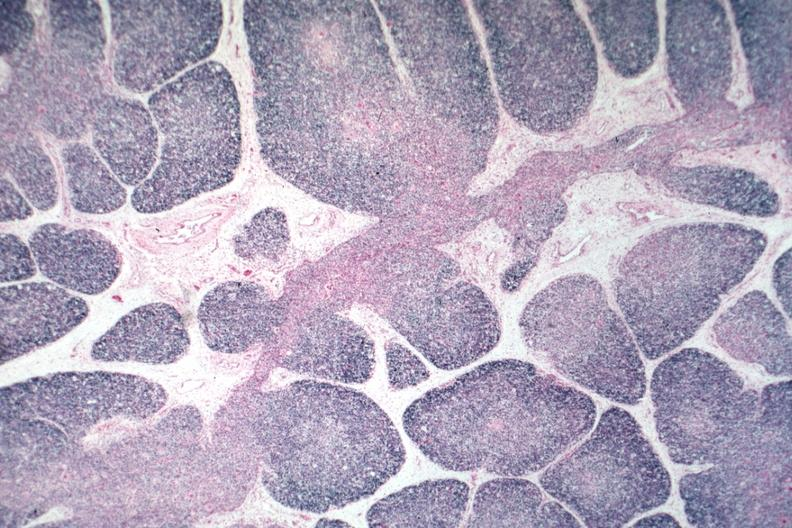s normal immature infant present?
Answer the question using a single word or phrase. Yes 